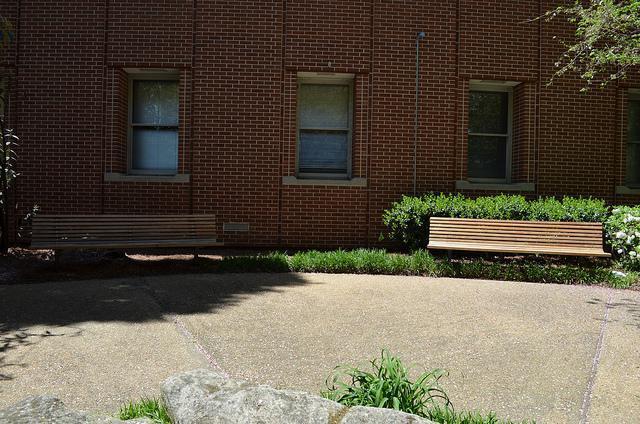How many benches are in the photo?
Give a very brief answer. 2. 